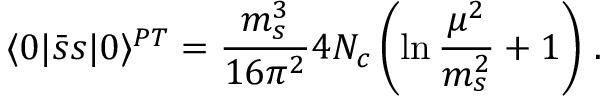<formula> <loc_0><loc_0><loc_500><loc_500>\langle 0 | \bar { s } s | 0 \rangle ^ { P T } = \frac { m _ { s } ^ { 3 } } { 1 6 \pi ^ { 2 } } 4 N _ { c } \left ( \ln \frac { \mu ^ { 2 } } { m _ { s } ^ { 2 } } + 1 \right ) \, .</formula> 